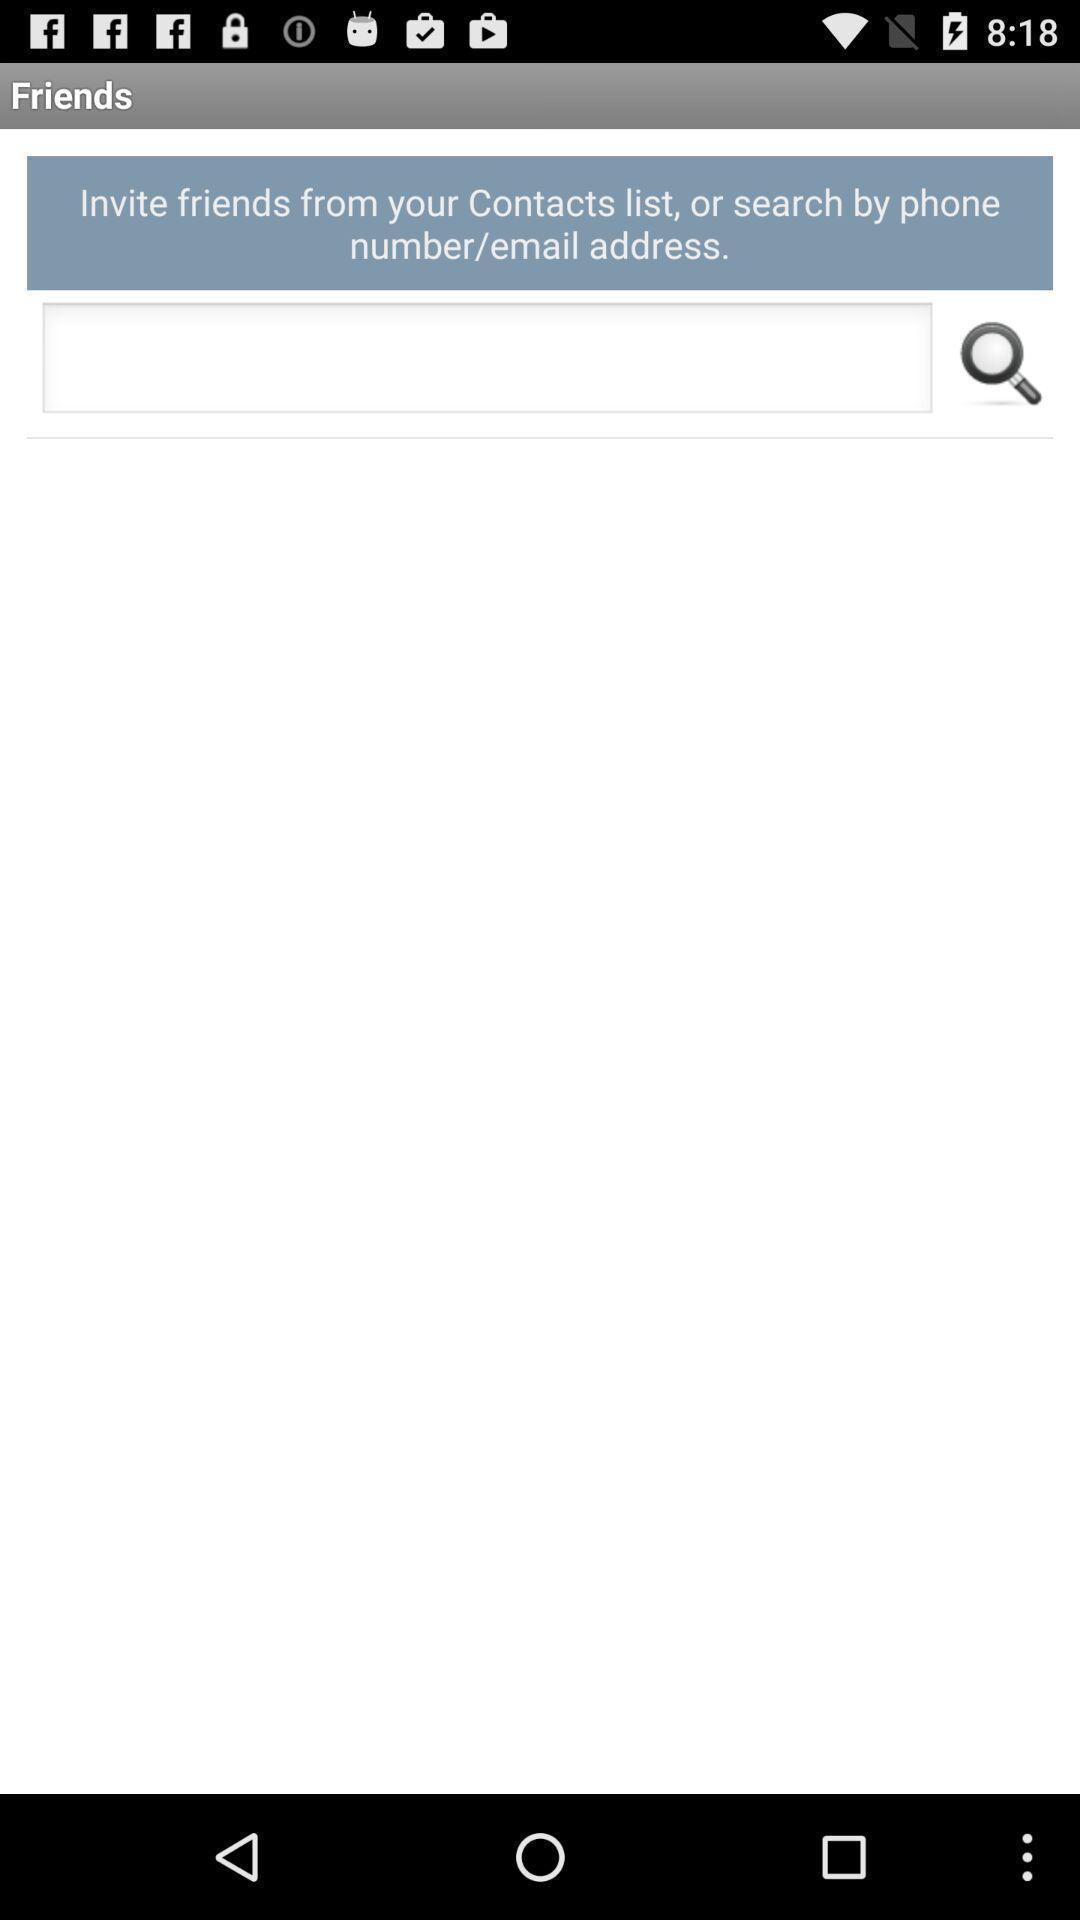Give me a summary of this screen capture. Search box showing in this page. 